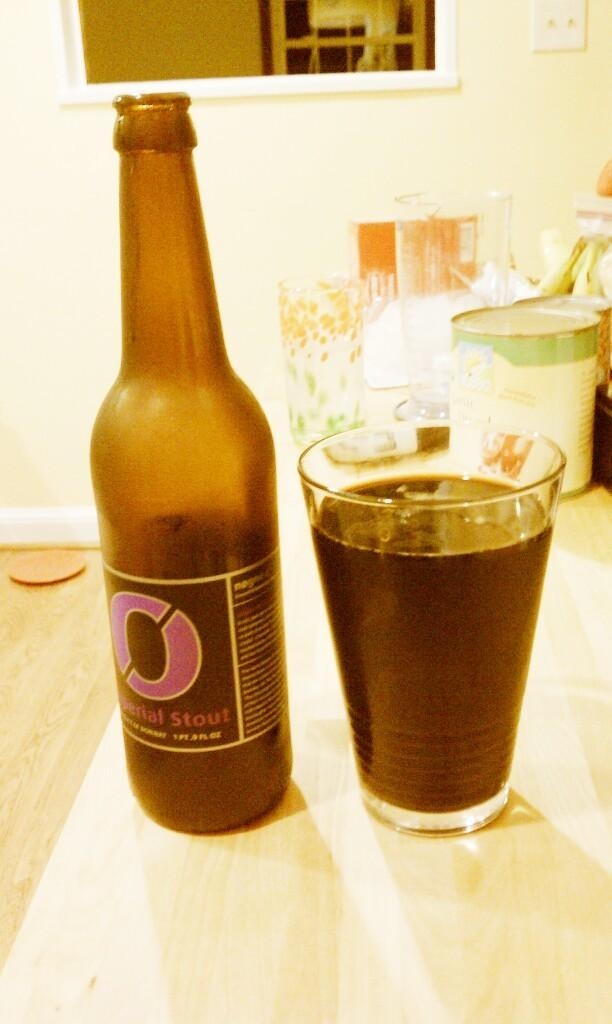<image>
Describe the image concisely. A bottle of Imperial Stout beer next to a cup of beer. 